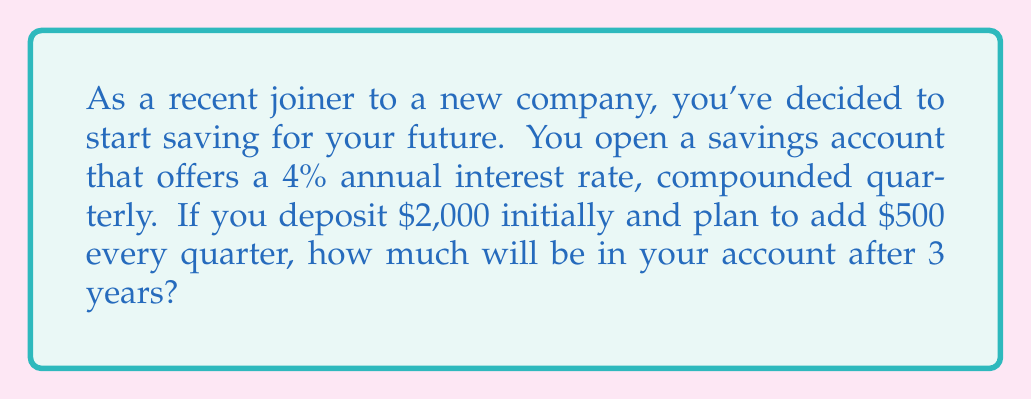Can you answer this question? To solve this problem, we'll use the compound interest formula with regular contributions:

$$A = P(1 + \frac{r}{n})^{nt} + C[\frac{(1 + \frac{r}{n})^{nt} - 1}{\frac{r}{n}}]$$

Where:
$A$ = Final amount
$P$ = Principal (initial deposit)
$r$ = Annual interest rate (as a decimal)
$n$ = Number of times interest is compounded per year
$t$ = Number of years
$C$ = Regular contribution amount

Given:
$P = 2000$
$r = 0.04$ (4% as a decimal)
$n = 4$ (compounded quarterly)
$t = 3$ years
$C = 500$ (quarterly contribution)

Let's substitute these values into the formula:

$$A = 2000(1 + \frac{0.04}{4})^{4(3)} + 500[\frac{(1 + \frac{0.04}{4})^{4(3)} - 1}{\frac{0.04}{4}}]$$

Simplifying:

$$A = 2000(1.01)^{12} + 500[\frac{(1.01)^{12} - 1}{0.01}]$$

Now, let's calculate step by step:

1. $(1.01)^{12} = 1.1268$
2. $2000(1.1268) = 2253.60$
3. $(1.1268 - 1) = 0.1268$
4. $0.1268 \div 0.01 = 12.68$
5. $500 \times 12.68 = 6340$

Adding the results from steps 2 and 5:

$$A = 2253.60 + 6340 = 8593.60$$

Therefore, after 3 years, the account will contain $8,593.60.
Answer: $8,593.60 